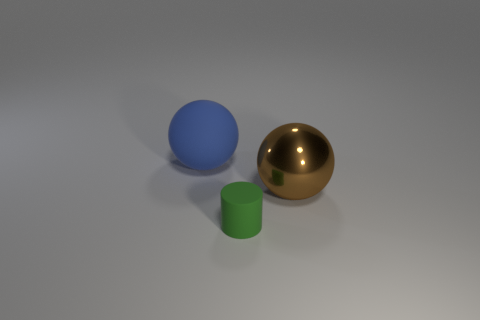Do the big ball that is on the right side of the tiny matte thing and the small matte cylinder on the right side of the rubber ball have the same color? no 